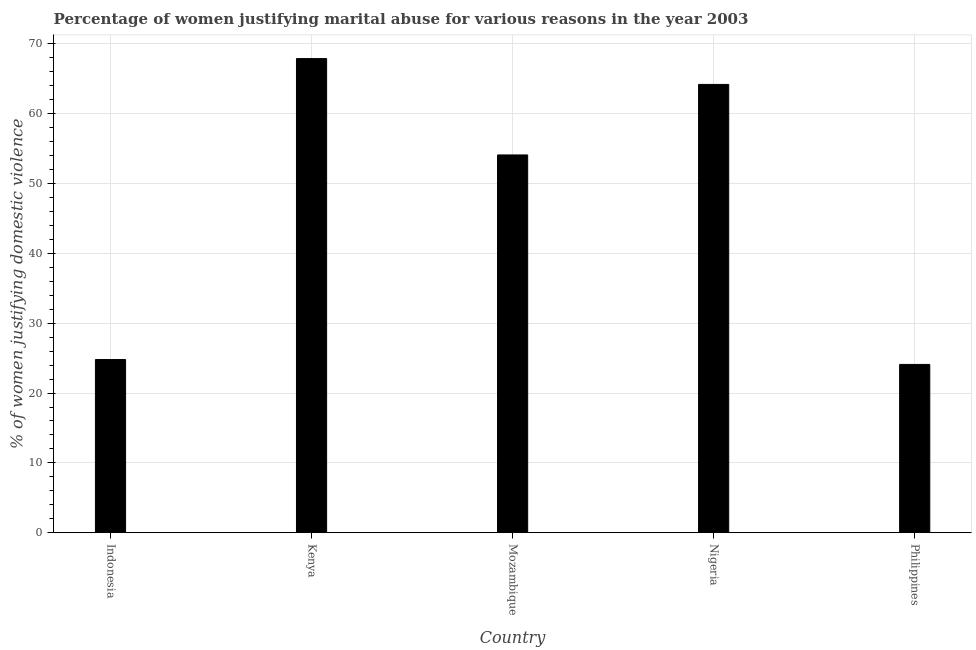Does the graph contain any zero values?
Offer a terse response. No. What is the title of the graph?
Your answer should be compact. Percentage of women justifying marital abuse for various reasons in the year 2003. What is the label or title of the X-axis?
Your answer should be compact. Country. What is the label or title of the Y-axis?
Make the answer very short. % of women justifying domestic violence. What is the percentage of women justifying marital abuse in Indonesia?
Offer a terse response. 24.8. Across all countries, what is the maximum percentage of women justifying marital abuse?
Provide a short and direct response. 67.9. Across all countries, what is the minimum percentage of women justifying marital abuse?
Provide a succinct answer. 24.1. In which country was the percentage of women justifying marital abuse maximum?
Your answer should be compact. Kenya. What is the sum of the percentage of women justifying marital abuse?
Give a very brief answer. 235.1. What is the difference between the percentage of women justifying marital abuse in Kenya and Nigeria?
Offer a very short reply. 3.7. What is the average percentage of women justifying marital abuse per country?
Offer a terse response. 47.02. What is the median percentage of women justifying marital abuse?
Provide a succinct answer. 54.1. In how many countries, is the percentage of women justifying marital abuse greater than 22 %?
Your response must be concise. 5. What is the ratio of the percentage of women justifying marital abuse in Indonesia to that in Nigeria?
Give a very brief answer. 0.39. Is the percentage of women justifying marital abuse in Nigeria less than that in Philippines?
Your answer should be compact. No. Is the difference between the percentage of women justifying marital abuse in Mozambique and Philippines greater than the difference between any two countries?
Provide a succinct answer. No. What is the difference between the highest and the second highest percentage of women justifying marital abuse?
Give a very brief answer. 3.7. What is the difference between the highest and the lowest percentage of women justifying marital abuse?
Your answer should be compact. 43.8. How many bars are there?
Ensure brevity in your answer.  5. Are all the bars in the graph horizontal?
Give a very brief answer. No. What is the difference between two consecutive major ticks on the Y-axis?
Your answer should be very brief. 10. Are the values on the major ticks of Y-axis written in scientific E-notation?
Provide a short and direct response. No. What is the % of women justifying domestic violence in Indonesia?
Keep it short and to the point. 24.8. What is the % of women justifying domestic violence of Kenya?
Provide a succinct answer. 67.9. What is the % of women justifying domestic violence in Mozambique?
Provide a short and direct response. 54.1. What is the % of women justifying domestic violence in Nigeria?
Provide a short and direct response. 64.2. What is the % of women justifying domestic violence of Philippines?
Your response must be concise. 24.1. What is the difference between the % of women justifying domestic violence in Indonesia and Kenya?
Keep it short and to the point. -43.1. What is the difference between the % of women justifying domestic violence in Indonesia and Mozambique?
Offer a terse response. -29.3. What is the difference between the % of women justifying domestic violence in Indonesia and Nigeria?
Your answer should be very brief. -39.4. What is the difference between the % of women justifying domestic violence in Kenya and Nigeria?
Provide a short and direct response. 3.7. What is the difference between the % of women justifying domestic violence in Kenya and Philippines?
Your answer should be very brief. 43.8. What is the difference between the % of women justifying domestic violence in Mozambique and Philippines?
Your answer should be compact. 30. What is the difference between the % of women justifying domestic violence in Nigeria and Philippines?
Your answer should be very brief. 40.1. What is the ratio of the % of women justifying domestic violence in Indonesia to that in Kenya?
Make the answer very short. 0.36. What is the ratio of the % of women justifying domestic violence in Indonesia to that in Mozambique?
Provide a short and direct response. 0.46. What is the ratio of the % of women justifying domestic violence in Indonesia to that in Nigeria?
Give a very brief answer. 0.39. What is the ratio of the % of women justifying domestic violence in Indonesia to that in Philippines?
Keep it short and to the point. 1.03. What is the ratio of the % of women justifying domestic violence in Kenya to that in Mozambique?
Offer a very short reply. 1.25. What is the ratio of the % of women justifying domestic violence in Kenya to that in Nigeria?
Keep it short and to the point. 1.06. What is the ratio of the % of women justifying domestic violence in Kenya to that in Philippines?
Offer a very short reply. 2.82. What is the ratio of the % of women justifying domestic violence in Mozambique to that in Nigeria?
Your response must be concise. 0.84. What is the ratio of the % of women justifying domestic violence in Mozambique to that in Philippines?
Give a very brief answer. 2.25. What is the ratio of the % of women justifying domestic violence in Nigeria to that in Philippines?
Your answer should be very brief. 2.66. 